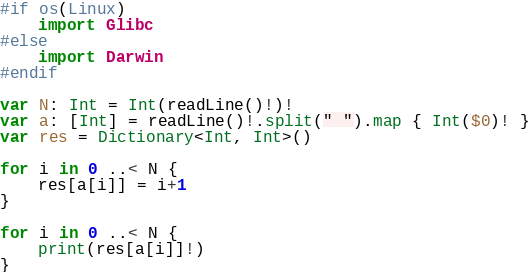Convert code to text. <code><loc_0><loc_0><loc_500><loc_500><_Swift_>#if os(Linux)
    import Glibc
#else
    import Darwin
#endif

var N: Int = Int(readLine()!)!
var a: [Int] = readLine()!.split(" ").map { Int($0)! }
var res = Dictionary<Int, Int>()

for i in 0 ..< N {
    res[a[i]] = i+1
}

for i in 0 ..< N {
    print(res[a[i]]!)
}</code> 